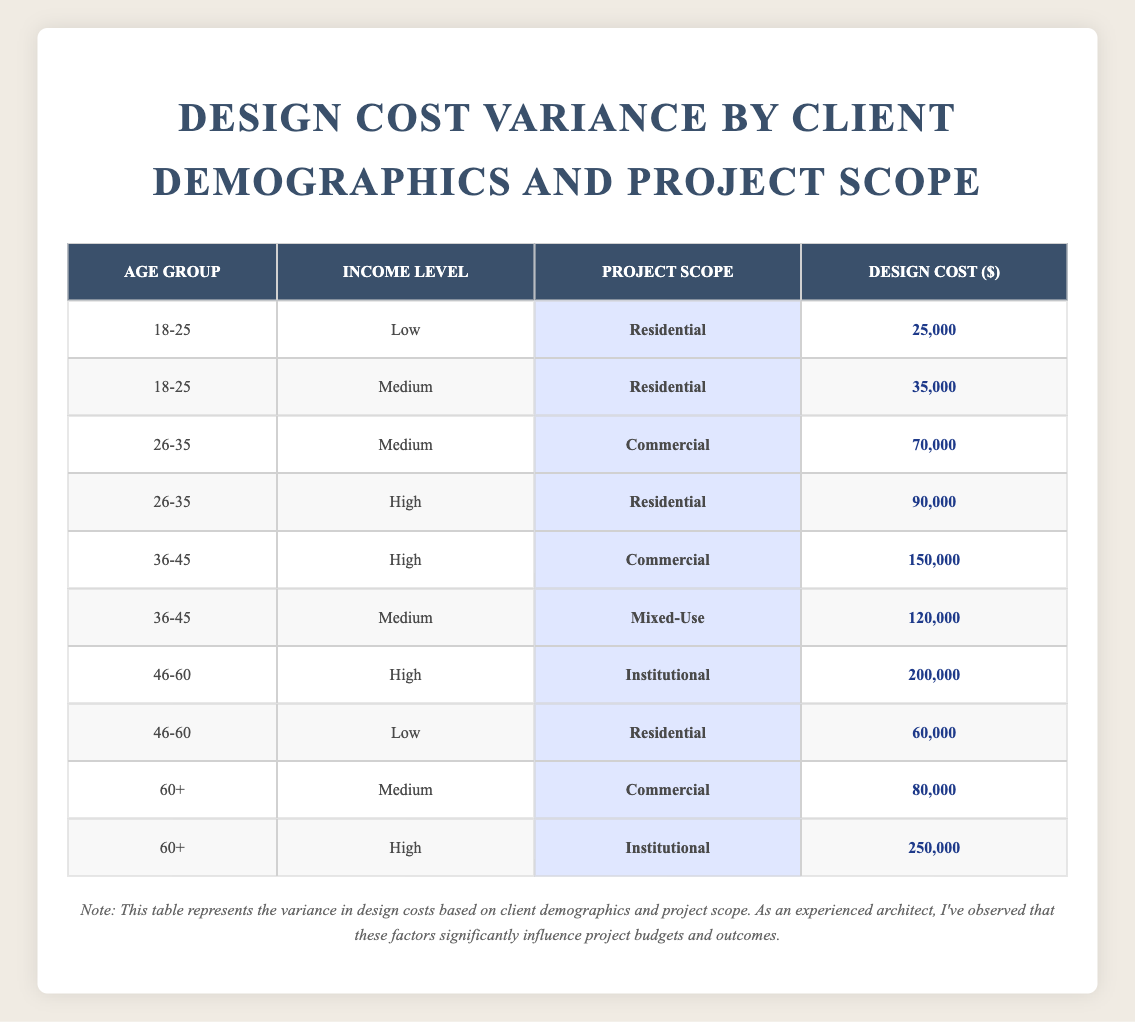What is the design cost for a Residential project by clients aged 18-25 with a Low income level? According to the table, for the age group 18-25 and income level Low, the project scope is Residential, and the design cost is 25,000.
Answer: 25,000 What is the design cost range for clients aged 46-60? The design costs for clients aged 46-60 are 60,000 and 200,000 based on their income levels. Therefore, the range is 60,000 to 200,000.
Answer: 60,000 to 200,000 Is there a project scope with a design cost less than 30,000? Reviewing the table, the lowest design cost is for the Residential project targeted at clients aged 18-25 with a Low income level, which is 25,000. Thus, the answer is yes.
Answer: Yes What is the total design cost for all projects in the table? To find the total design cost, we sum all the costs: 25,000 + 35,000 + 70,000 + 90,000 + 150,000 + 120,000 + 200,000 + 60,000 + 80,000 + 250,000 = 1,110,000.
Answer: 1,110,000 Which age group has the highest average design costs across all income levels and project scopes? For age groups, we calculate the average costs: 18-25: (25,000 + 35,000) / 2 = 30,000; 26-35: (70,000 + 90,000) / 2 = 80,000; 36-45: (150,000 + 120,000) / 2 = 135,000; 46-60: (200,000 + 60,000) / 2 = 130,000; 60+: (80,000 + 250,000) / 2 = 165,000. The highest average is for age group 60+ which is 165,000.
Answer: 60+ What is the design cost for a Medium income level in a Mixed-Use project? Looking at the table, there is only one instance of Medium income level in a Mixed-Use project, which corresponds to clients aged 36-45, and the design cost is 120,000.
Answer: 120,000 